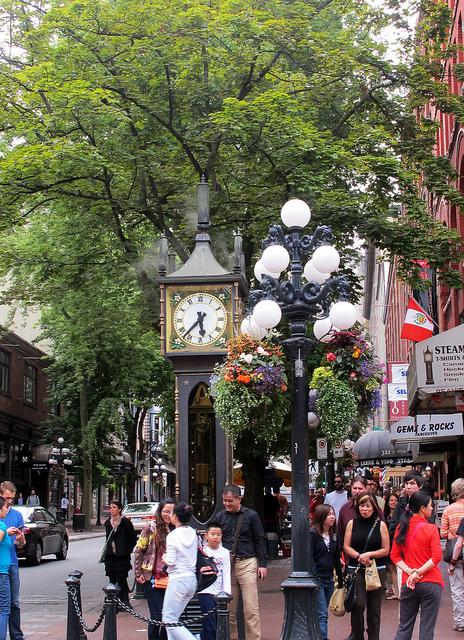What is coming out of the clock? Please explain your reasoning. steam. A cloudy, misty area surround clocks on a pole on a sidewalk. 